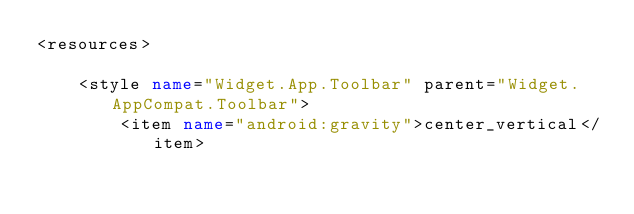<code> <loc_0><loc_0><loc_500><loc_500><_XML_><resources>

    <style name="Widget.App.Toolbar" parent="Widget.AppCompat.Toolbar">
        <item name="android:gravity">center_vertical</item></code> 